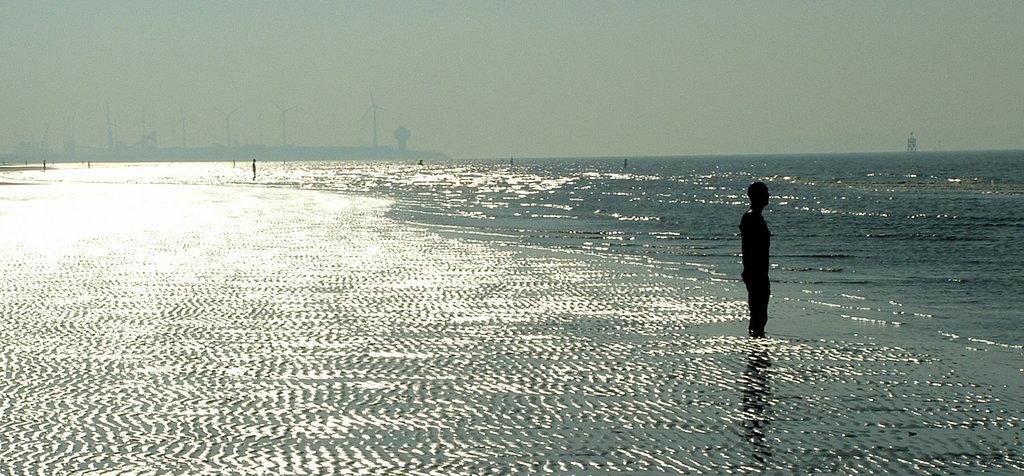How would you summarize this image in a sentence or two? In this picture there is a man who is standing on the right side of the image, in the water and there is water around the area of the image, there are windmills on the left side of the image. 